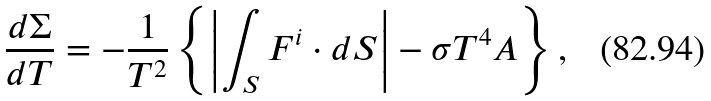Convert formula to latex. <formula><loc_0><loc_0><loc_500><loc_500>\frac { d \Sigma } { d T } = - \frac { 1 } { T ^ { 2 } } \left \{ \left | \int _ { S } { F } ^ { i } \cdot d { S } \right | - \sigma T ^ { 4 } A \right \} ,</formula> 